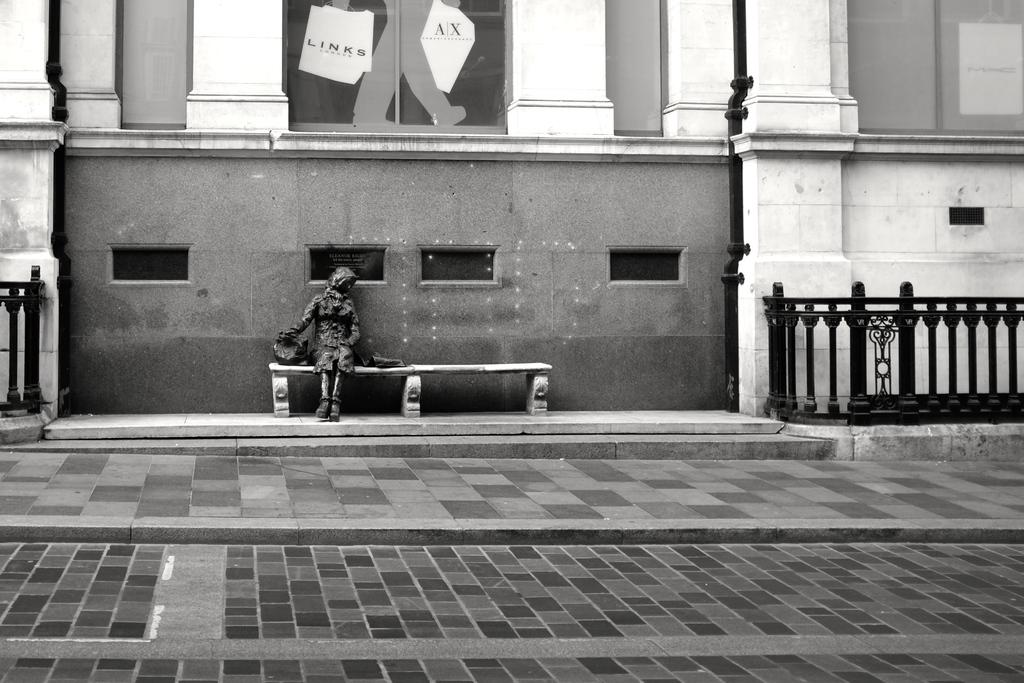What is the color scheme of the image? The image is black and white. What is the person in the image doing? The person is sitting on a bench. What is behind the person in the image? The person is in front of a big wall. What other architectural features are present in the image? There are pillars beside the wall. Can you tell me how many birds are sitting on the person's shoulder in the image? There are no birds present in the image. What type of alley can be seen behind the person in the image? There is: There is no alley visible in the image; it features a big wall and pillars. 